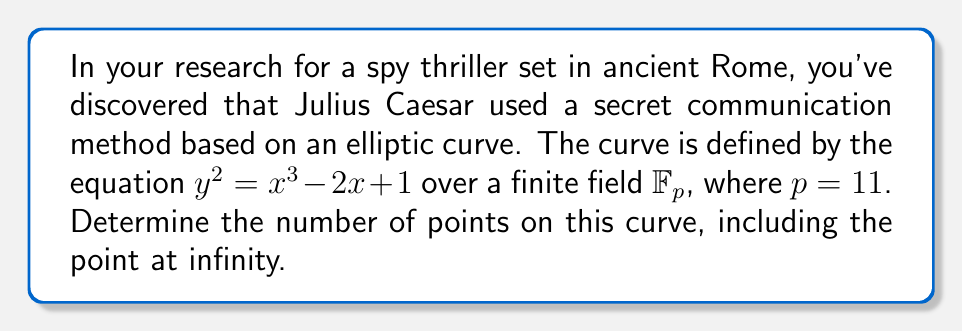Teach me how to tackle this problem. To solve this problem, we'll follow these steps:

1) First, we need to check all possible x-coordinates in $\mathbb{F}_{11}$ (0 to 10) and determine which ones result in a perfect square for $y^2$.

2) For each x, calculate $x^3 - 2x + 1 \mod 11$:

   For $x = 0$: $0^3 - 2(0) + 1 \equiv 1 \pmod{11}$
   For $x = 1$: $1^3 - 2(1) + 1 \equiv 0 \pmod{11}$
   For $x = 2$: $2^3 - 2(2) + 1 \equiv 5 \pmod{11}$
   For $x = 3$: $3^3 - 2(3) + 1 \equiv 7 \pmod{11}$
   For $x = 4$: $4^3 - 2(4) + 1 \equiv 9 \pmod{11}$
   For $x = 5$: $5^3 - 2(5) + 1 \equiv 10 \pmod{11}$
   For $x = 6$: $6^3 - 2(6) + 1 \equiv 10 \pmod{11}$
   For $x = 7$: $7^3 - 2(7) + 1 \equiv 9 \pmod{11}$
   For $x = 8$: $8^3 - 2(8) + 1 \equiv 7 \pmod{11}$
   For $x = 9$: $9^3 - 2(9) + 1 \equiv 5 \pmod{11}$
   For $x = 10$: $10^3 - 2(10) + 1 \equiv 3 \pmod{11}$

3) Now, we need to check which of these results are perfect squares in $\mathbb{F}_{11}$. The perfect squares in $\mathbb{F}_{11}$ are 0, 1, 4, 9, 5, 3.

4) Counting the points:
   - For $x = 0$, $y^2 = 1$, which has two solutions: $y = \pm 1$
   - For $x = 1$, $y^2 = 0$, which has one solution: $y = 0$
   - For $x = 2$, $y^2 = 5$, which has two solutions: $y = \pm 4$
   - For $x = 9$, $y^2 = 5$, which has two solutions: $y = \pm 4$
   - For $x = 10$, $y^2 = 3$, which has two solutions: $y = \pm 5$

5) In total, we have 9 points on the curve.

6) Finally, we need to include the point at infinity, which is always on an elliptic curve.

Therefore, the total number of points on this elliptic curve, including the point at infinity, is 10.
Answer: 10 points 